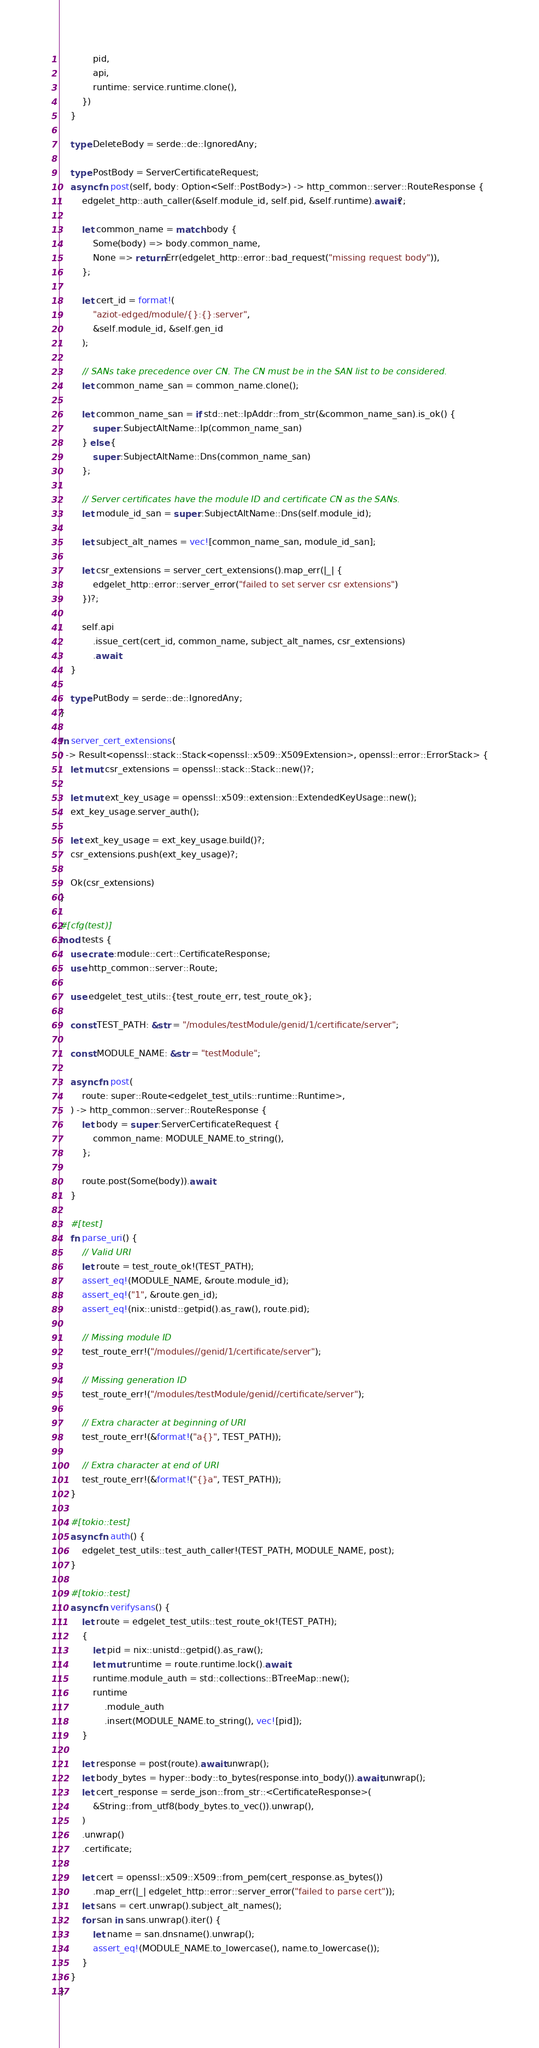Convert code to text. <code><loc_0><loc_0><loc_500><loc_500><_Rust_>            pid,
            api,
            runtime: service.runtime.clone(),
        })
    }

    type DeleteBody = serde::de::IgnoredAny;

    type PostBody = ServerCertificateRequest;
    async fn post(self, body: Option<Self::PostBody>) -> http_common::server::RouteResponse {
        edgelet_http::auth_caller(&self.module_id, self.pid, &self.runtime).await?;

        let common_name = match body {
            Some(body) => body.common_name,
            None => return Err(edgelet_http::error::bad_request("missing request body")),
        };

        let cert_id = format!(
            "aziot-edged/module/{}:{}:server",
            &self.module_id, &self.gen_id
        );

        // SANs take precedence over CN. The CN must be in the SAN list to be considered.
        let common_name_san = common_name.clone();

        let common_name_san = if std::net::IpAddr::from_str(&common_name_san).is_ok() {
            super::SubjectAltName::Ip(common_name_san)
        } else {
            super::SubjectAltName::Dns(common_name_san)
        };

        // Server certificates have the module ID and certificate CN as the SANs.
        let module_id_san = super::SubjectAltName::Dns(self.module_id);

        let subject_alt_names = vec![common_name_san, module_id_san];

        let csr_extensions = server_cert_extensions().map_err(|_| {
            edgelet_http::error::server_error("failed to set server csr extensions")
        })?;

        self.api
            .issue_cert(cert_id, common_name, subject_alt_names, csr_extensions)
            .await
    }

    type PutBody = serde::de::IgnoredAny;
}

fn server_cert_extensions(
) -> Result<openssl::stack::Stack<openssl::x509::X509Extension>, openssl::error::ErrorStack> {
    let mut csr_extensions = openssl::stack::Stack::new()?;

    let mut ext_key_usage = openssl::x509::extension::ExtendedKeyUsage::new();
    ext_key_usage.server_auth();

    let ext_key_usage = ext_key_usage.build()?;
    csr_extensions.push(ext_key_usage)?;

    Ok(csr_extensions)
}

#[cfg(test)]
mod tests {
    use crate::module::cert::CertificateResponse;
    use http_common::server::Route;

    use edgelet_test_utils::{test_route_err, test_route_ok};

    const TEST_PATH: &str = "/modules/testModule/genid/1/certificate/server";

    const MODULE_NAME: &str = "testModule";

    async fn post(
        route: super::Route<edgelet_test_utils::runtime::Runtime>,
    ) -> http_common::server::RouteResponse {
        let body = super::ServerCertificateRequest {
            common_name: MODULE_NAME.to_string(),
        };

        route.post(Some(body)).await
    }

    #[test]
    fn parse_uri() {
        // Valid URI
        let route = test_route_ok!(TEST_PATH);
        assert_eq!(MODULE_NAME, &route.module_id);
        assert_eq!("1", &route.gen_id);
        assert_eq!(nix::unistd::getpid().as_raw(), route.pid);

        // Missing module ID
        test_route_err!("/modules//genid/1/certificate/server");

        // Missing generation ID
        test_route_err!("/modules/testModule/genid//certificate/server");

        // Extra character at beginning of URI
        test_route_err!(&format!("a{}", TEST_PATH));

        // Extra character at end of URI
        test_route_err!(&format!("{}a", TEST_PATH));
    }

    #[tokio::test]
    async fn auth() {
        edgelet_test_utils::test_auth_caller!(TEST_PATH, MODULE_NAME, post);
    }

    #[tokio::test]
    async fn verifysans() {
        let route = edgelet_test_utils::test_route_ok!(TEST_PATH);
        {
            let pid = nix::unistd::getpid().as_raw();
            let mut runtime = route.runtime.lock().await;
            runtime.module_auth = std::collections::BTreeMap::new();
            runtime
                .module_auth
                .insert(MODULE_NAME.to_string(), vec![pid]);
        }

        let response = post(route).await.unwrap();
        let body_bytes = hyper::body::to_bytes(response.into_body()).await.unwrap();
        let cert_response = serde_json::from_str::<CertificateResponse>(
            &String::from_utf8(body_bytes.to_vec()).unwrap(),
        )
        .unwrap()
        .certificate;

        let cert = openssl::x509::X509::from_pem(cert_response.as_bytes())
            .map_err(|_| edgelet_http::error::server_error("failed to parse cert"));
        let sans = cert.unwrap().subject_alt_names();
        for san in sans.unwrap().iter() {
            let name = san.dnsname().unwrap();
            assert_eq!(MODULE_NAME.to_lowercase(), name.to_lowercase());
        }
    }
}
</code> 